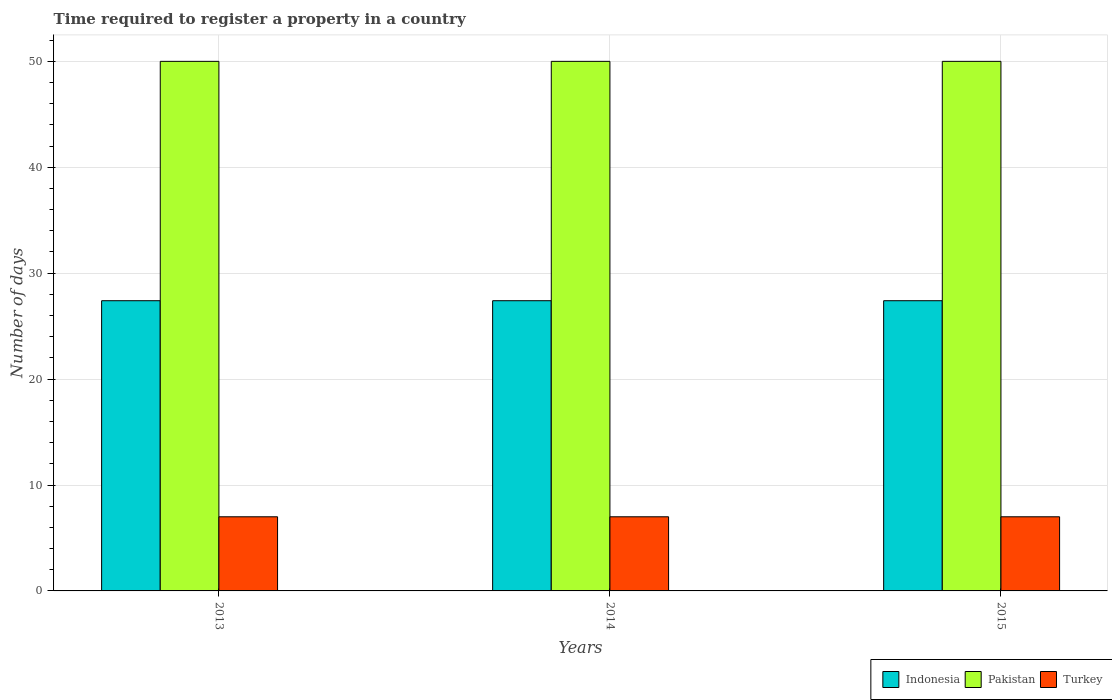How many different coloured bars are there?
Make the answer very short. 3. Are the number of bars per tick equal to the number of legend labels?
Provide a succinct answer. Yes. Are the number of bars on each tick of the X-axis equal?
Give a very brief answer. Yes. How many bars are there on the 3rd tick from the right?
Offer a terse response. 3. What is the label of the 2nd group of bars from the left?
Ensure brevity in your answer.  2014. Across all years, what is the maximum number of days required to register a property in Indonesia?
Provide a short and direct response. 27.4. Across all years, what is the minimum number of days required to register a property in Pakistan?
Keep it short and to the point. 50. What is the total number of days required to register a property in Turkey in the graph?
Your response must be concise. 21. What is the difference between the number of days required to register a property in Turkey in 2013 and that in 2015?
Give a very brief answer. 0. What is the difference between the number of days required to register a property in Indonesia in 2015 and the number of days required to register a property in Turkey in 2013?
Ensure brevity in your answer.  20.4. In the year 2015, what is the difference between the number of days required to register a property in Indonesia and number of days required to register a property in Turkey?
Provide a succinct answer. 20.4. What is the ratio of the number of days required to register a property in Turkey in 2013 to that in 2014?
Keep it short and to the point. 1. Is the number of days required to register a property in Indonesia in 2013 less than that in 2014?
Give a very brief answer. No. Is the difference between the number of days required to register a property in Indonesia in 2013 and 2015 greater than the difference between the number of days required to register a property in Turkey in 2013 and 2015?
Your answer should be compact. No. What is the difference between the highest and the second highest number of days required to register a property in Indonesia?
Make the answer very short. 0. What is the difference between the highest and the lowest number of days required to register a property in Indonesia?
Give a very brief answer. 0. Is the sum of the number of days required to register a property in Indonesia in 2013 and 2014 greater than the maximum number of days required to register a property in Pakistan across all years?
Ensure brevity in your answer.  Yes. What does the 1st bar from the left in 2015 represents?
Give a very brief answer. Indonesia. What does the 1st bar from the right in 2013 represents?
Give a very brief answer. Turkey. How many bars are there?
Ensure brevity in your answer.  9. Are all the bars in the graph horizontal?
Your response must be concise. No. How many years are there in the graph?
Your answer should be very brief. 3. What is the difference between two consecutive major ticks on the Y-axis?
Your answer should be very brief. 10. Does the graph contain any zero values?
Keep it short and to the point. No. Does the graph contain grids?
Give a very brief answer. Yes. Where does the legend appear in the graph?
Your response must be concise. Bottom right. What is the title of the graph?
Your answer should be very brief. Time required to register a property in a country. Does "Sint Maarten (Dutch part)" appear as one of the legend labels in the graph?
Your answer should be compact. No. What is the label or title of the Y-axis?
Offer a terse response. Number of days. What is the Number of days of Indonesia in 2013?
Ensure brevity in your answer.  27.4. What is the Number of days of Pakistan in 2013?
Your response must be concise. 50. What is the Number of days of Turkey in 2013?
Offer a very short reply. 7. What is the Number of days in Indonesia in 2014?
Make the answer very short. 27.4. What is the Number of days of Indonesia in 2015?
Your answer should be compact. 27.4. Across all years, what is the maximum Number of days in Indonesia?
Ensure brevity in your answer.  27.4. Across all years, what is the minimum Number of days of Indonesia?
Offer a terse response. 27.4. Across all years, what is the minimum Number of days in Pakistan?
Your answer should be compact. 50. Across all years, what is the minimum Number of days of Turkey?
Your answer should be very brief. 7. What is the total Number of days of Indonesia in the graph?
Keep it short and to the point. 82.2. What is the total Number of days in Pakistan in the graph?
Ensure brevity in your answer.  150. What is the total Number of days in Turkey in the graph?
Your answer should be very brief. 21. What is the difference between the Number of days of Indonesia in 2013 and that in 2014?
Ensure brevity in your answer.  0. What is the difference between the Number of days of Pakistan in 2013 and that in 2014?
Give a very brief answer. 0. What is the difference between the Number of days in Turkey in 2013 and that in 2014?
Your answer should be very brief. 0. What is the difference between the Number of days in Indonesia in 2013 and that in 2015?
Keep it short and to the point. 0. What is the difference between the Number of days of Turkey in 2013 and that in 2015?
Your answer should be compact. 0. What is the difference between the Number of days of Indonesia in 2014 and that in 2015?
Ensure brevity in your answer.  0. What is the difference between the Number of days in Turkey in 2014 and that in 2015?
Make the answer very short. 0. What is the difference between the Number of days of Indonesia in 2013 and the Number of days of Pakistan in 2014?
Offer a terse response. -22.6. What is the difference between the Number of days in Indonesia in 2013 and the Number of days in Turkey in 2014?
Give a very brief answer. 20.4. What is the difference between the Number of days of Pakistan in 2013 and the Number of days of Turkey in 2014?
Give a very brief answer. 43. What is the difference between the Number of days of Indonesia in 2013 and the Number of days of Pakistan in 2015?
Your response must be concise. -22.6. What is the difference between the Number of days of Indonesia in 2013 and the Number of days of Turkey in 2015?
Offer a very short reply. 20.4. What is the difference between the Number of days of Indonesia in 2014 and the Number of days of Pakistan in 2015?
Make the answer very short. -22.6. What is the difference between the Number of days in Indonesia in 2014 and the Number of days in Turkey in 2015?
Provide a short and direct response. 20.4. What is the average Number of days of Indonesia per year?
Provide a short and direct response. 27.4. In the year 2013, what is the difference between the Number of days in Indonesia and Number of days in Pakistan?
Make the answer very short. -22.6. In the year 2013, what is the difference between the Number of days of Indonesia and Number of days of Turkey?
Provide a short and direct response. 20.4. In the year 2013, what is the difference between the Number of days of Pakistan and Number of days of Turkey?
Your response must be concise. 43. In the year 2014, what is the difference between the Number of days in Indonesia and Number of days in Pakistan?
Your answer should be very brief. -22.6. In the year 2014, what is the difference between the Number of days of Indonesia and Number of days of Turkey?
Your answer should be compact. 20.4. In the year 2014, what is the difference between the Number of days in Pakistan and Number of days in Turkey?
Offer a very short reply. 43. In the year 2015, what is the difference between the Number of days in Indonesia and Number of days in Pakistan?
Your response must be concise. -22.6. In the year 2015, what is the difference between the Number of days in Indonesia and Number of days in Turkey?
Your response must be concise. 20.4. In the year 2015, what is the difference between the Number of days of Pakistan and Number of days of Turkey?
Make the answer very short. 43. What is the ratio of the Number of days in Indonesia in 2013 to that in 2014?
Your response must be concise. 1. What is the ratio of the Number of days of Indonesia in 2013 to that in 2015?
Provide a short and direct response. 1. What is the ratio of the Number of days in Pakistan in 2013 to that in 2015?
Ensure brevity in your answer.  1. What is the ratio of the Number of days in Indonesia in 2014 to that in 2015?
Provide a succinct answer. 1. What is the ratio of the Number of days in Turkey in 2014 to that in 2015?
Make the answer very short. 1. What is the difference between the highest and the second highest Number of days of Pakistan?
Provide a succinct answer. 0. What is the difference between the highest and the lowest Number of days in Turkey?
Provide a short and direct response. 0. 